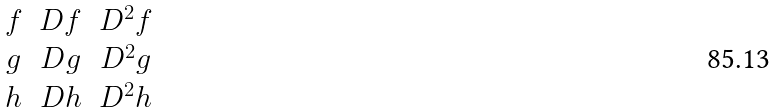Convert formula to latex. <formula><loc_0><loc_0><loc_500><loc_500>\begin{matrix} f & D f & D ^ { 2 } f \\ g & D g & D ^ { 2 } g \\ h & D h & D ^ { 2 } h \end{matrix}</formula> 